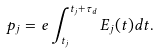<formula> <loc_0><loc_0><loc_500><loc_500>p _ { j } = e \int _ { t _ { j } } ^ { t _ { j } + \tau _ { d } } E _ { j } ( t ) d t .</formula> 